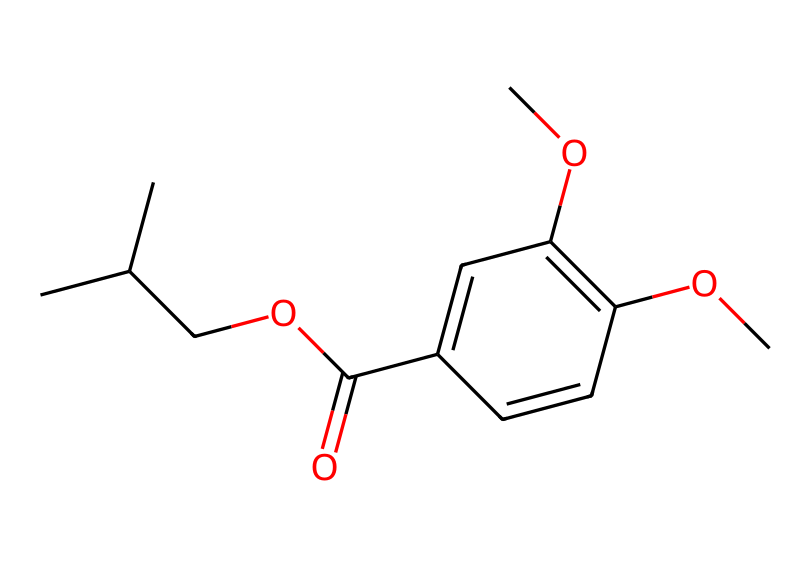What is the molecular formula of this chemical? To determine the molecular formula, we count the number of each type of atom present in the SMILES representation. The given SMILES is CC(C)COC(=O)C1=CC(=C(C=C1)OC)OC. From the structure, we identify 13 carbon atoms, 16 hydrogen atoms, and 5 oxygen atoms. Thus, the molecular formula is C13H16O5.
Answer: C13H16O5 How many oxygen atoms are present in this chemical? Counting directly from the molecular formula, we can see that there are 5 oxygen atoms (O) in C13H16O5.
Answer: 5 Is this chemical likely to be hydrophilic or hydrophobic? The presence of multiple oxygen atoms suggests that this chemical has polar characteristics, which are typical of hydrophilic substances. Many hydroxyl (–OH) and ether (–O–) functional groups can enhance water solubility.
Answer: hydrophilic What class of compounds does this chemical belong to? By examining the functional groups present (specifically the ester and aromatic structures), we identify this chemical as belonging to the class of phenolic esters or possibly as a component used in insect repellents. These compounds are often used for their insect-repelling properties.
Answer: phenolic ester What is the function of the ester group in this chemical? The ester group (–COOC–) in insect repellents often contributes to the volatility and ability to form fragrances, influencing how effectively the repellents can evaporate and create a protective layer against insects. This makes them suitable for outdoor use.
Answer: repellent function What might be a safety consideration regarding the use of this chemical outdoors? A potential safety consideration includes allergic reactions or skin irritation, particularly for children, who may have more sensitive skin. It's important to follow usage guidelines to minimize adverse effects during outdoor play.
Answer: allergic reactions 